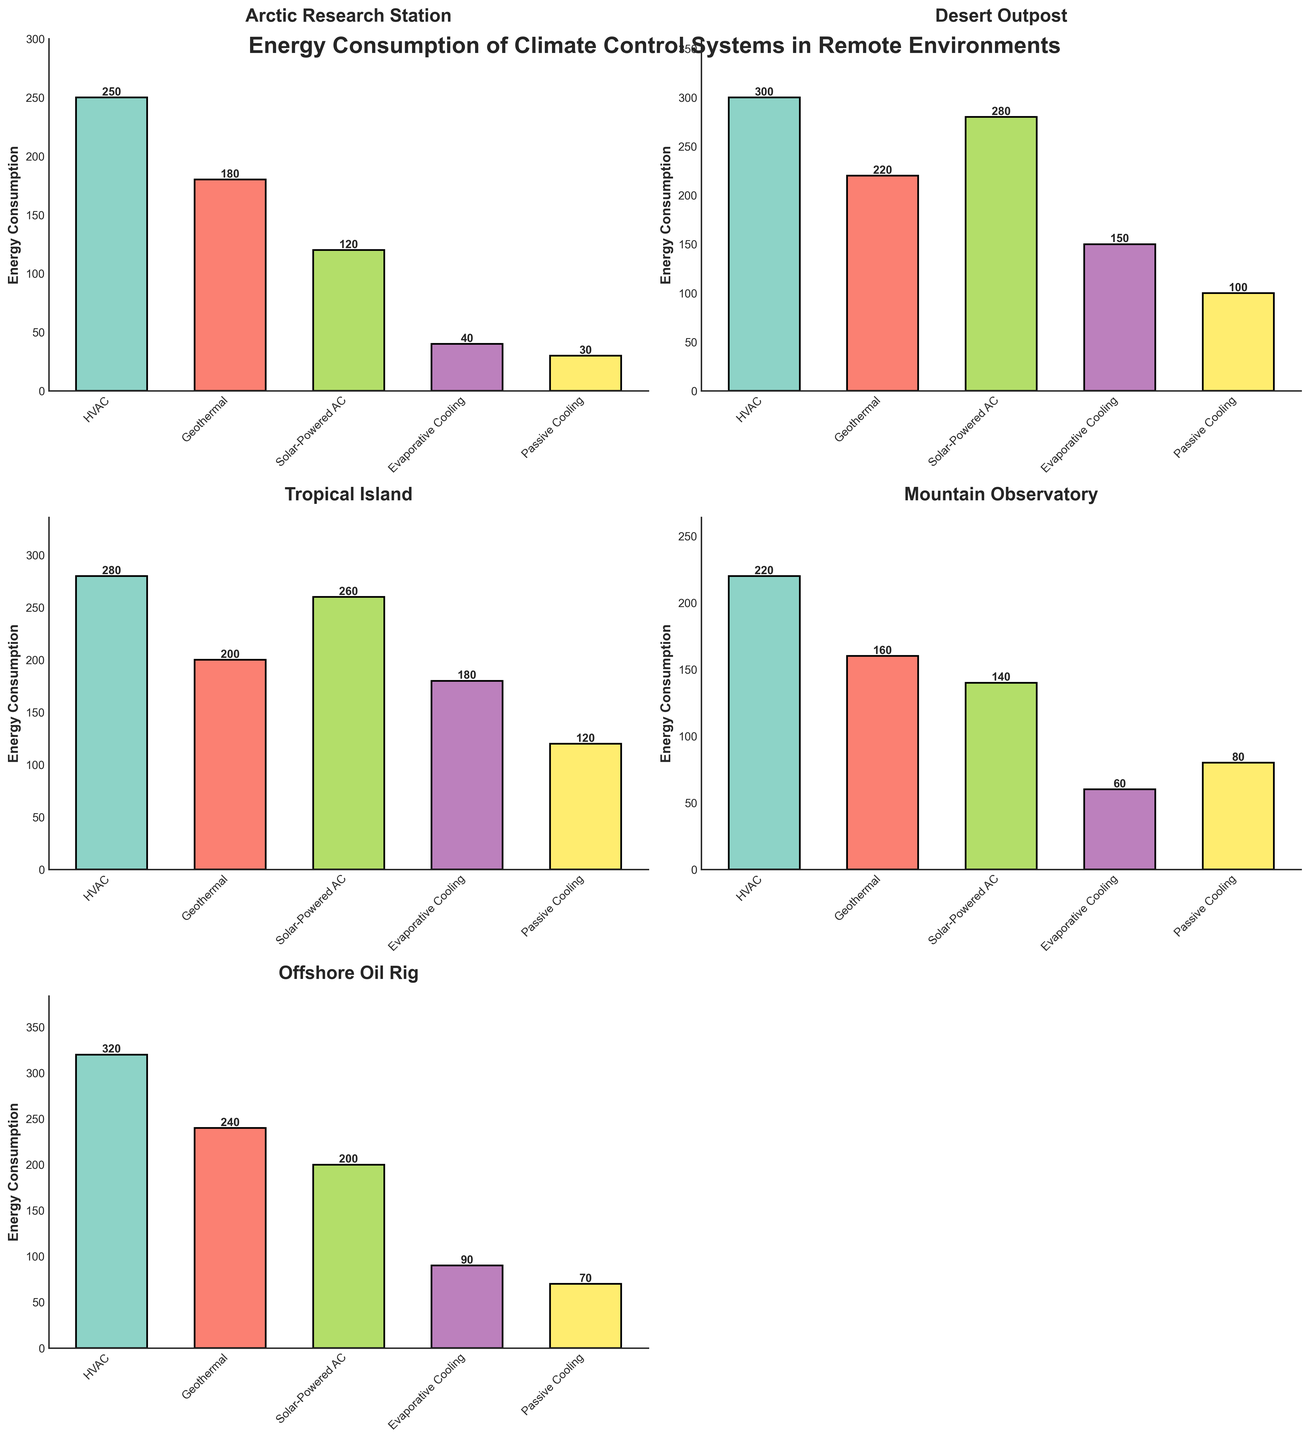Which environment has the highest energy consumption for HVAC systems? Look at the bar chart corresponding to each environment and find the bar labeled 'HVAC'. The Arctic Research Station has a value of 250, Desert Outpost has 300, Tropical Island has 280, Mountain Observatory has 220, and Offshore Oil Rig has 320. The highest value is 320 at the Offshore Oil Rig.
Answer: Offshore Oil Rig What is the total energy consumption for Solar-Powered AC across all environments? Sum the heights of the bars labeled 'Solar-Powered AC' across all environments. Arctic Research Station: 120, Desert Outpost: 280, Tropical Island: 260, Mountain Observatory: 140, Offshore Oil Rig: 200. 120 + 280 + 260 + 140 + 200 = 1000
Answer: 1000 Which climate control system has the least energy consumption in the Desert Outpost? Look at the bar chart for the Desert Outpost and compare the heights of all the bars. The heights are HVAC: 300, Geothermal: 220, Solar-Powered AC: 280, Evaporative Cooling: 150, Passive Cooling: 100. The smallest bar is 'Passive Cooling' with a value of 100.
Answer: Passive Cooling How does the energy consumption of Geothermal systems in the Arctic Research Station compare to the Mountain Observatory? Look at the bar labeled 'Geothermal' in the Arctic Research Station and Mountain Observatory sections. Arctic Research Station has 180, and Mountain Observatory has 160. 180 > 160.
Answer: Arctic Research Station has higher Geothermal consumption What is the average energy consumption of Passive Cooling systems across all environments? Sum the heights of the 'Passive Cooling' bars across all environments and divide by the number of environments. Arctic Research Station: 30, Desert Outpost: 100, Tropical Island: 120, Mountain Observatory: 80, and Offshore Oil Rig: 70. Total = 30 + 100 + 120 + 80 + 70 = 400. Average = 400 / 5 = 80
Answer: 80 